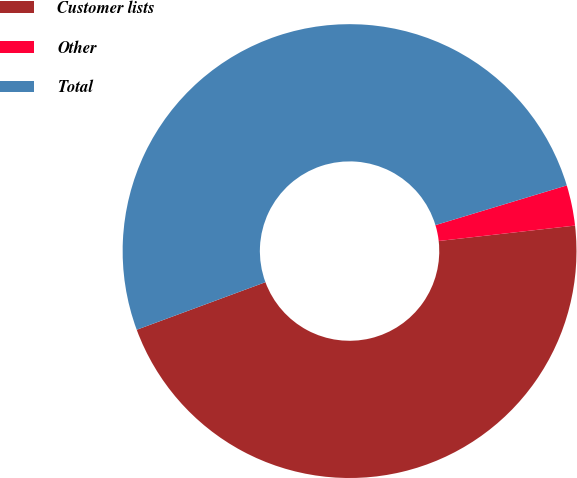Convert chart to OTSL. <chart><loc_0><loc_0><loc_500><loc_500><pie_chart><fcel>Customer lists<fcel>Other<fcel>Total<nl><fcel>46.16%<fcel>2.88%<fcel>50.96%<nl></chart> 